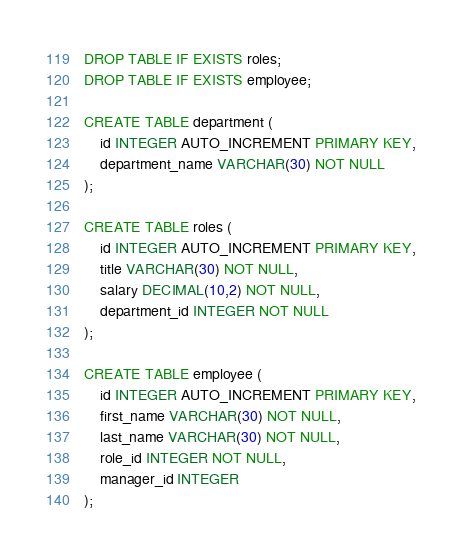<code> <loc_0><loc_0><loc_500><loc_500><_SQL_>DROP TABLE IF EXISTS roles;
DROP TABLE IF EXISTS employee;

CREATE TABLE department (
    id INTEGER AUTO_INCREMENT PRIMARY KEY,
    department_name VARCHAR(30) NOT NULL
);

CREATE TABLE roles (
    id INTEGER AUTO_INCREMENT PRIMARY KEY,
    title VARCHAR(30) NOT NULL,
    salary DECIMAL(10,2) NOT NULL,
    department_id INTEGER NOT NULL
);

CREATE TABLE employee (
    id INTEGER AUTO_INCREMENT PRIMARY KEY,
    first_name VARCHAR(30) NOT NULL,
    last_name VARCHAR(30) NOT NULL,
    role_id INTEGER NOT NULL,
    manager_id INTEGER
);</code> 